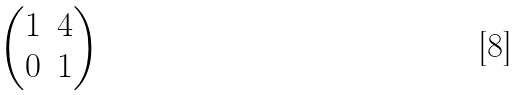<formula> <loc_0><loc_0><loc_500><loc_500>\begin{pmatrix} 1 & 4 \\ 0 & 1 \\ \end{pmatrix}</formula> 